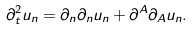<formula> <loc_0><loc_0><loc_500><loc_500>\partial ^ { 2 } _ { t } u _ { n } = \partial _ { n } \partial _ { n } u _ { n } + \partial ^ { A } \partial _ { A } u _ { n } .</formula> 